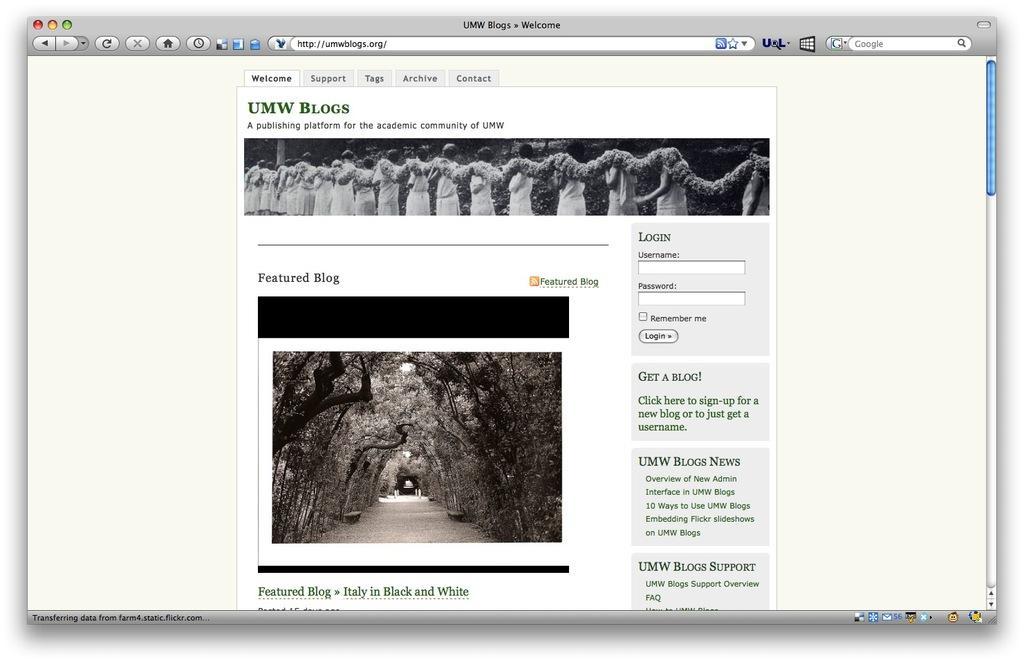Could you give a brief overview of what you see in this image? In this image there is a screenshot of a screen. 